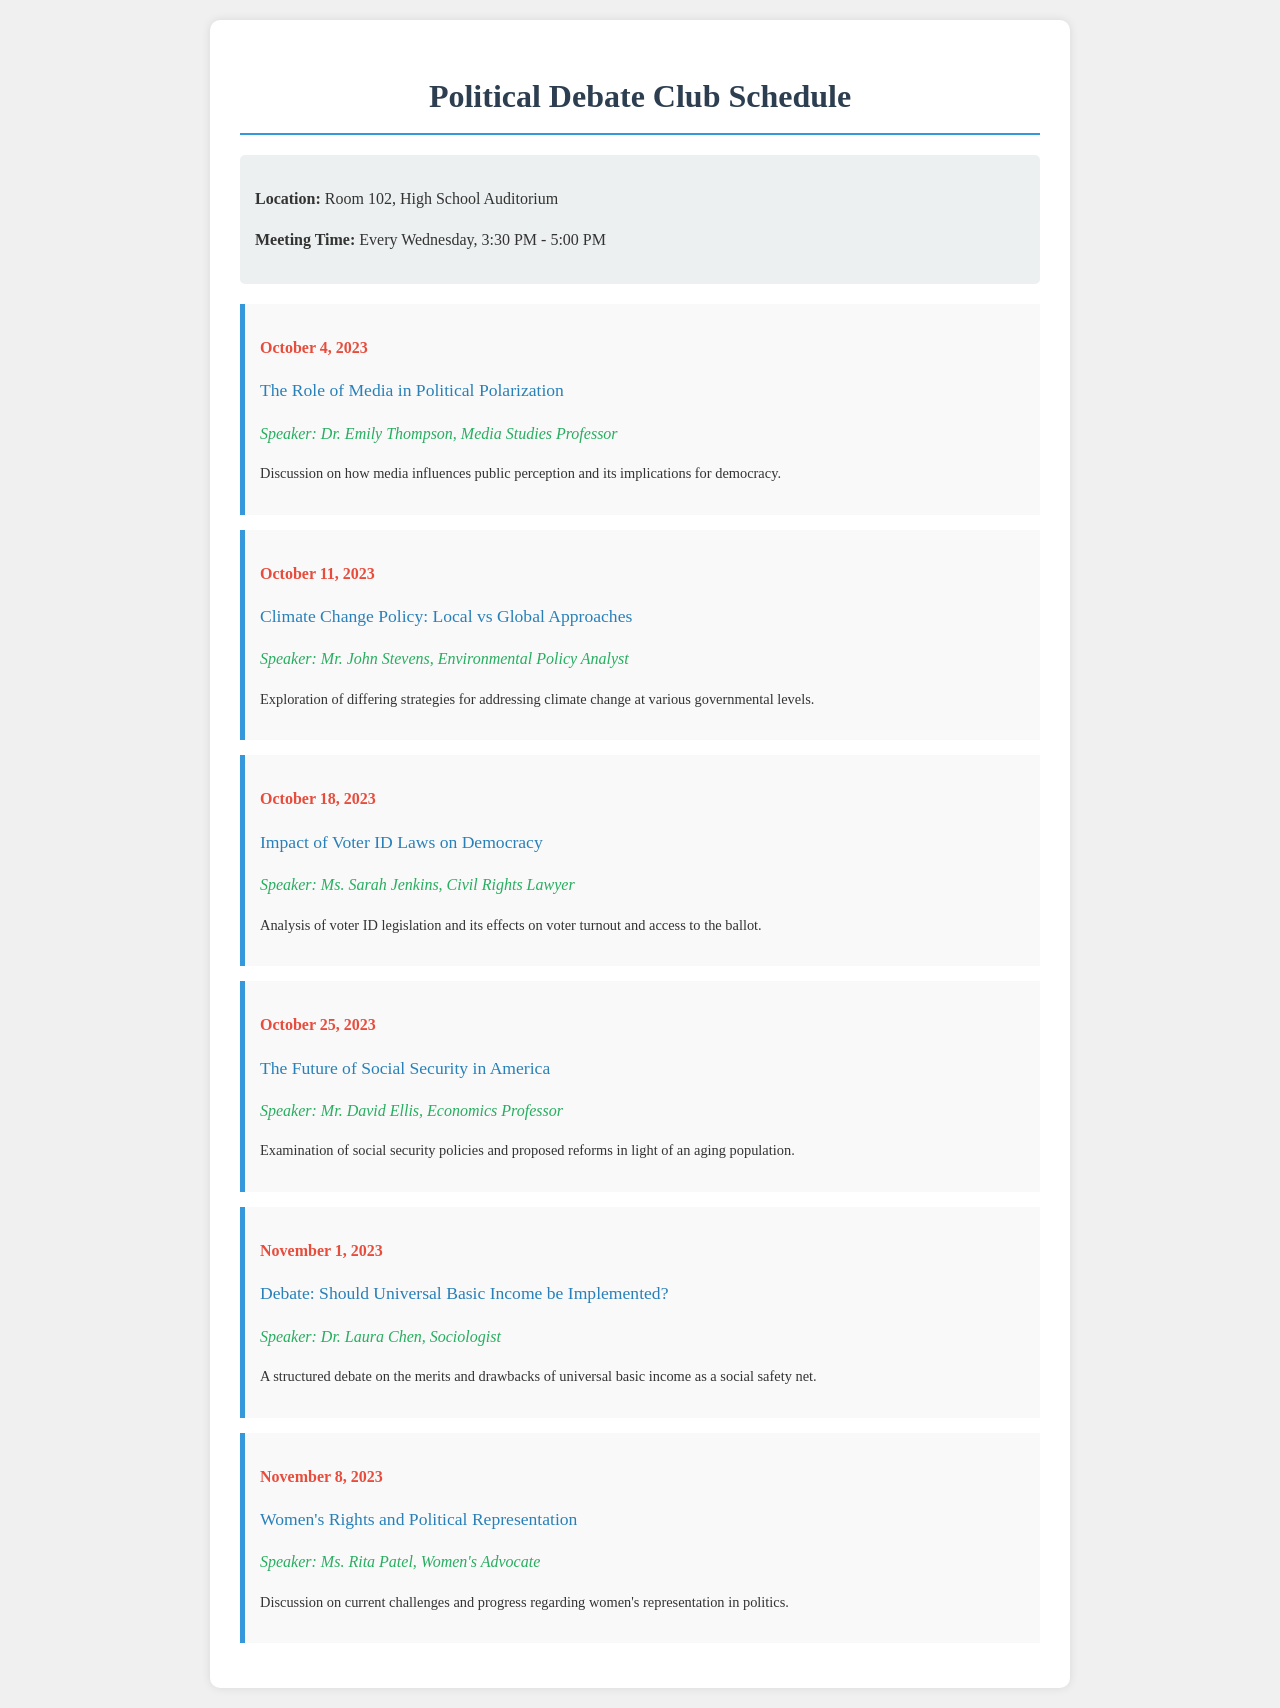what is the location of the Political Debate Club meetings? The location is explicitly stated in the document as "Room 102, High School Auditorium."
Answer: Room 102, High School Auditorium what time do the meetings occur? The document specifies that the meetings are held every Wednesday from 3:30 PM to 5:00 PM.
Answer: 3:30 PM - 5:00 PM who is the speaker for the session on October 18, 2023? The document lists Ms. Sarah Jenkins as the speaker for that date, regarding voter ID laws.
Answer: Ms. Sarah Jenkins what is the topic of the meeting on November 1, 2023? The document indicates that the topic is about a structured debate on universal basic income.
Answer: Debate: Should Universal Basic Income be Implemented? how many sessions are scheduled in total? Counting the sessions listed in the document gives us a total of six scheduled sessions.
Answer: 6 which speaker focuses on women's rights? The document mentions Ms. Rita Patel as the speaker addressing women's representation in politics.
Answer: Ms. Rita Patel what is the date of the first session? The first session is detailed in the document as occurring on October 4, 2023.
Answer: October 4, 2023 what topic will be discussed on October 25, 2023? The document shows that the topic for October 25, 2023, is "The Future of Social Security in America."
Answer: The Future of Social Security in America what subject will Mr. John Stevens discuss? The document reveals that Mr. John Stevens will speak on climate change policy.
Answer: Climate Change Policy: Local vs Global Approaches 